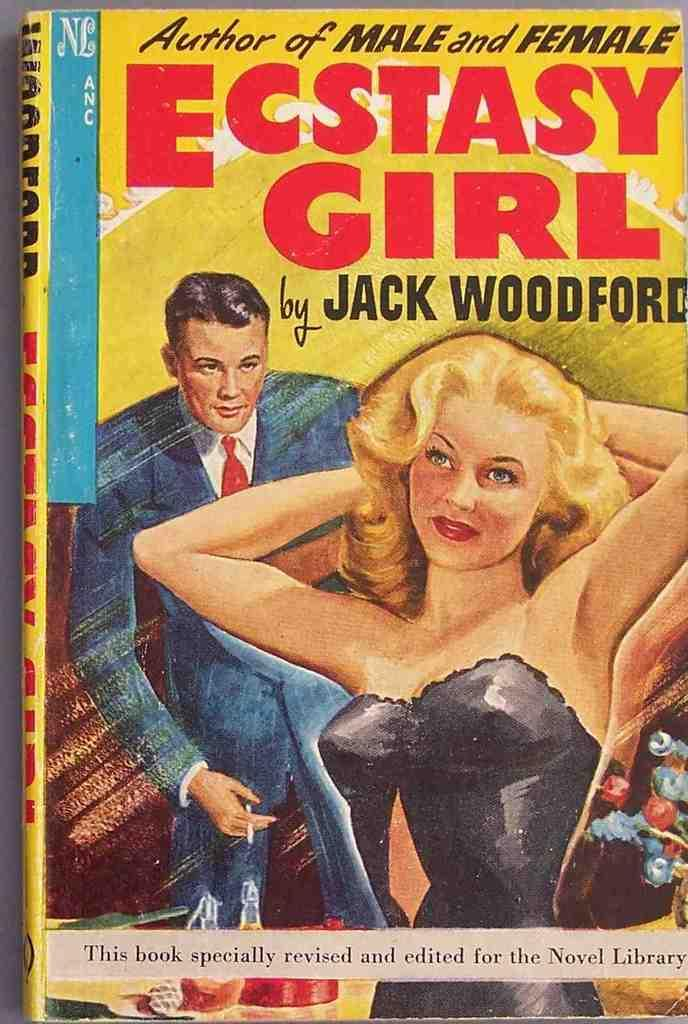<image>
Describe the image concisely. A Novel Book with the title of "Ecstasy Girl" was revised and edited specifically for Novel Library. 